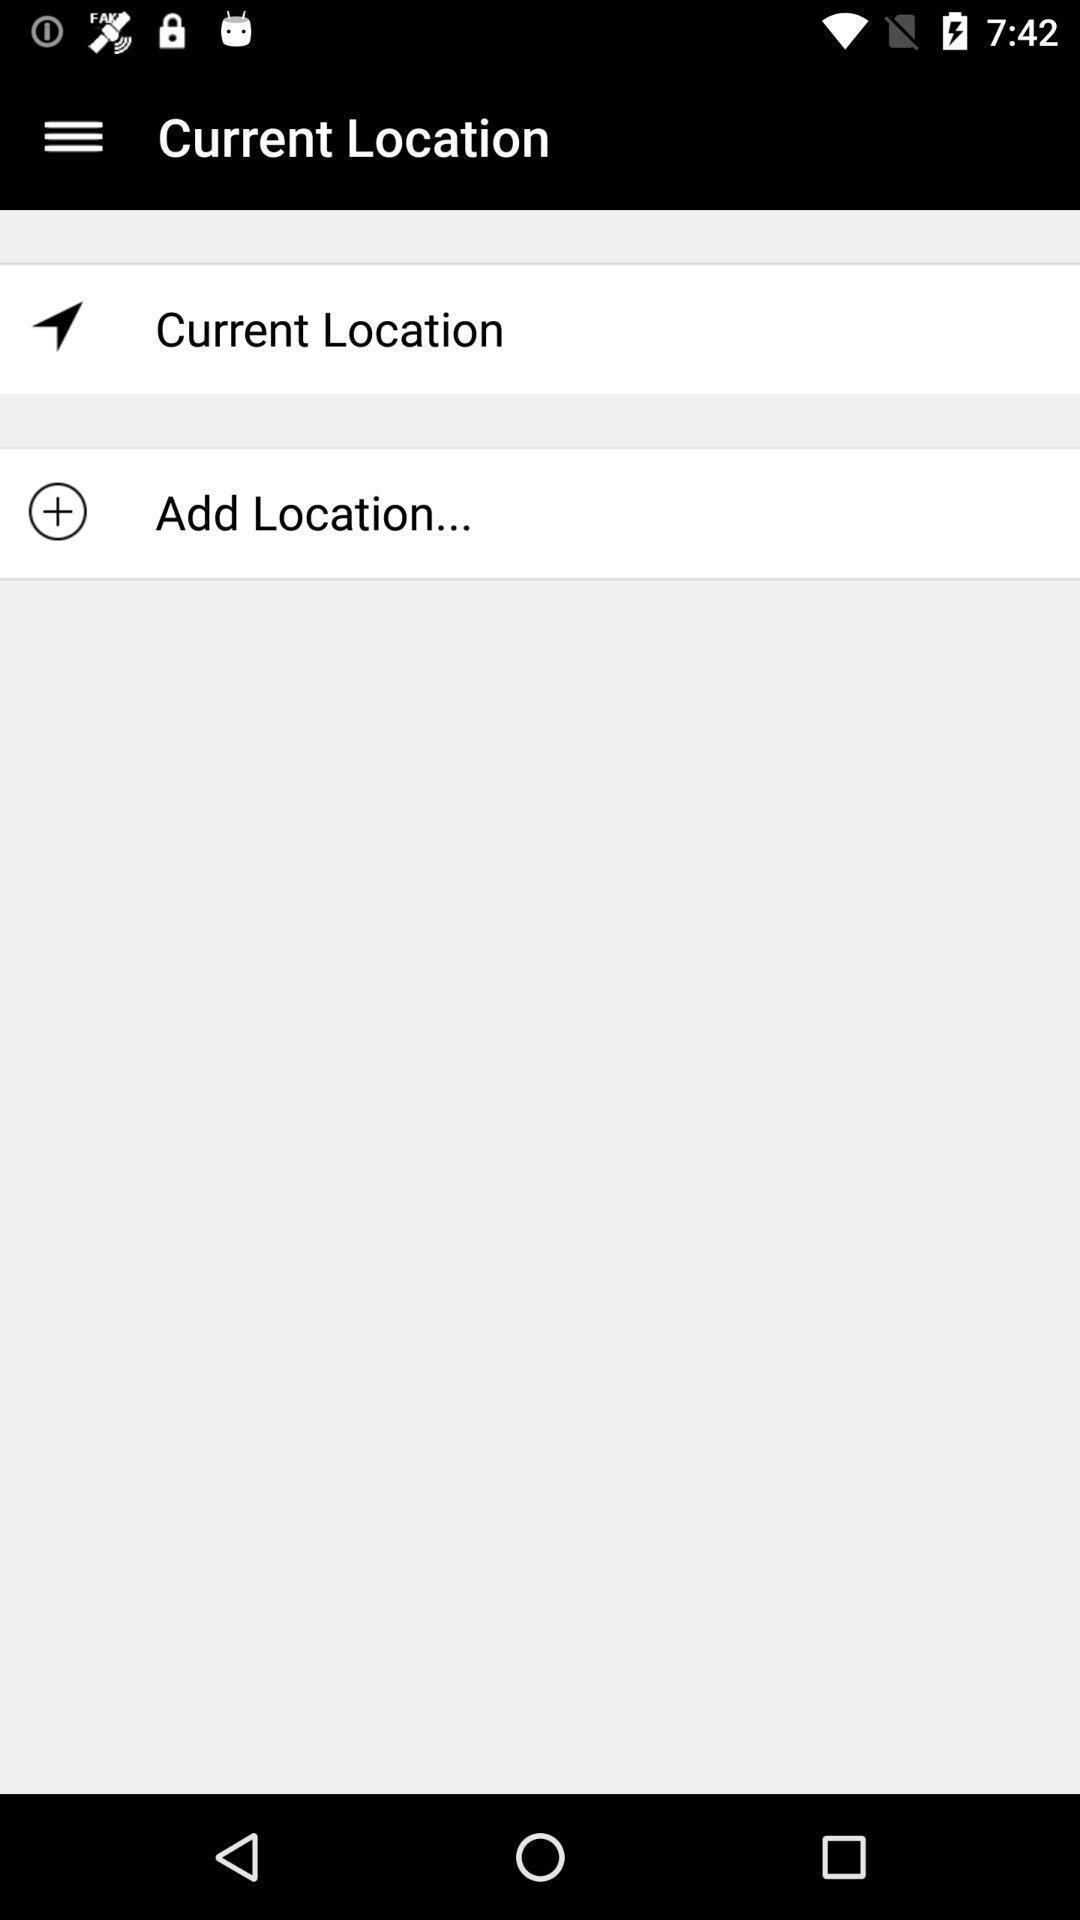What can you discern from this picture? Page showing different options on a navigational app. 